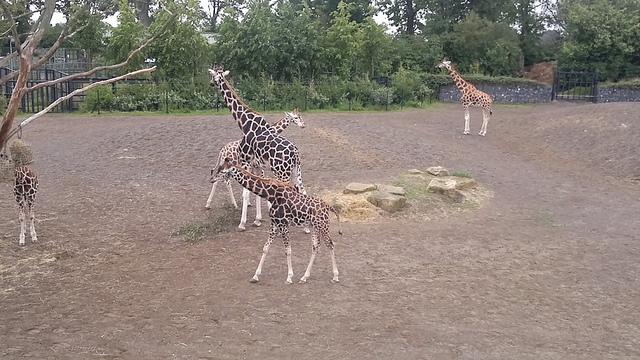How many animals are there?
Be succinct. 5. Is there an animal only partially in frame?
Keep it brief. No. Are these animals in a zoo?
Write a very short answer. Yes. 